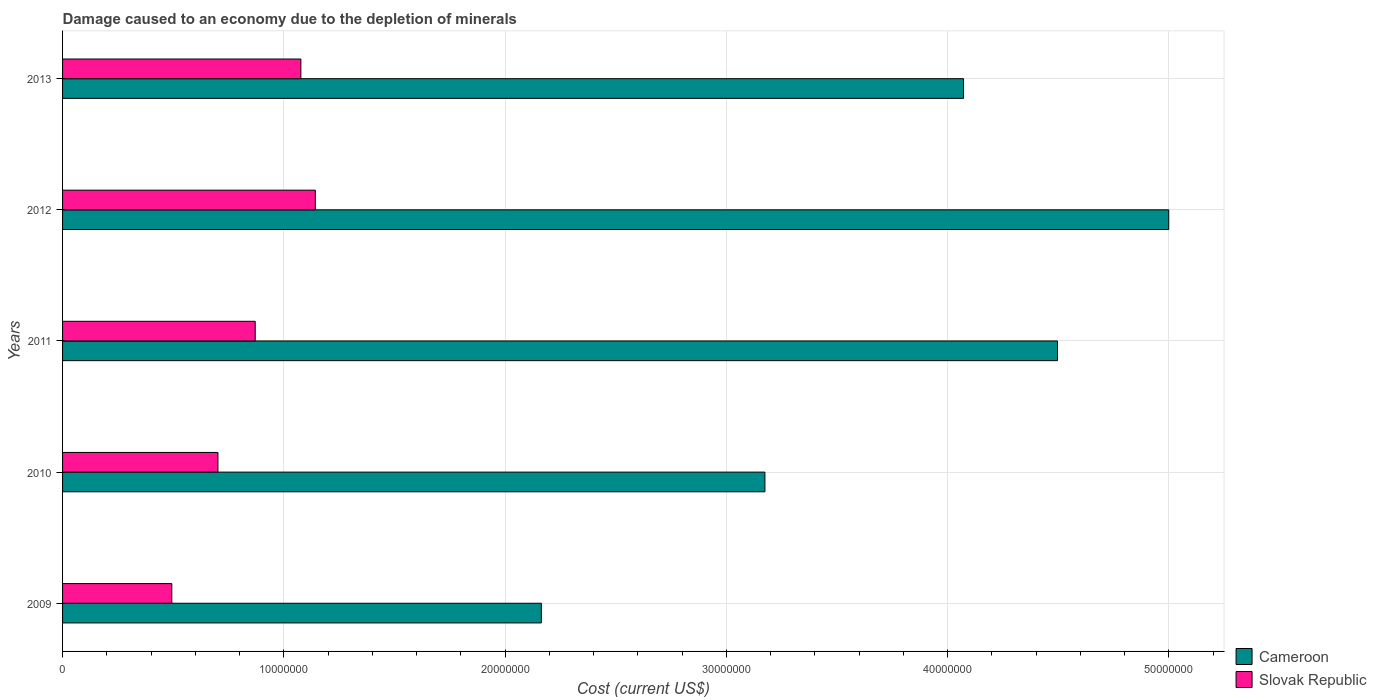How many groups of bars are there?
Provide a short and direct response. 5. Are the number of bars per tick equal to the number of legend labels?
Your answer should be compact. Yes. Are the number of bars on each tick of the Y-axis equal?
Offer a terse response. Yes. How many bars are there on the 4th tick from the bottom?
Make the answer very short. 2. What is the label of the 1st group of bars from the top?
Provide a short and direct response. 2013. What is the cost of damage caused due to the depletion of minerals in Slovak Republic in 2011?
Your answer should be very brief. 8.71e+06. Across all years, what is the maximum cost of damage caused due to the depletion of minerals in Slovak Republic?
Offer a terse response. 1.14e+07. Across all years, what is the minimum cost of damage caused due to the depletion of minerals in Cameroon?
Make the answer very short. 2.16e+07. What is the total cost of damage caused due to the depletion of minerals in Cameroon in the graph?
Provide a succinct answer. 1.89e+08. What is the difference between the cost of damage caused due to the depletion of minerals in Slovak Republic in 2009 and that in 2010?
Ensure brevity in your answer.  -2.08e+06. What is the difference between the cost of damage caused due to the depletion of minerals in Slovak Republic in 2010 and the cost of damage caused due to the depletion of minerals in Cameroon in 2012?
Your answer should be compact. -4.30e+07. What is the average cost of damage caused due to the depletion of minerals in Cameroon per year?
Your answer should be compact. 3.78e+07. In the year 2011, what is the difference between the cost of damage caused due to the depletion of minerals in Cameroon and cost of damage caused due to the depletion of minerals in Slovak Republic?
Your answer should be very brief. 3.63e+07. What is the ratio of the cost of damage caused due to the depletion of minerals in Cameroon in 2012 to that in 2013?
Provide a short and direct response. 1.23. Is the cost of damage caused due to the depletion of minerals in Cameroon in 2009 less than that in 2011?
Your answer should be very brief. Yes. Is the difference between the cost of damage caused due to the depletion of minerals in Cameroon in 2010 and 2011 greater than the difference between the cost of damage caused due to the depletion of minerals in Slovak Republic in 2010 and 2011?
Provide a short and direct response. No. What is the difference between the highest and the second highest cost of damage caused due to the depletion of minerals in Cameroon?
Your answer should be compact. 5.03e+06. What is the difference between the highest and the lowest cost of damage caused due to the depletion of minerals in Slovak Republic?
Provide a short and direct response. 6.49e+06. In how many years, is the cost of damage caused due to the depletion of minerals in Slovak Republic greater than the average cost of damage caused due to the depletion of minerals in Slovak Republic taken over all years?
Make the answer very short. 3. What does the 1st bar from the top in 2012 represents?
Your response must be concise. Slovak Republic. What does the 2nd bar from the bottom in 2011 represents?
Give a very brief answer. Slovak Republic. How many bars are there?
Keep it short and to the point. 10. How many years are there in the graph?
Your answer should be very brief. 5. Are the values on the major ticks of X-axis written in scientific E-notation?
Offer a very short reply. No. Does the graph contain any zero values?
Your answer should be compact. No. Does the graph contain grids?
Provide a short and direct response. Yes. What is the title of the graph?
Keep it short and to the point. Damage caused to an economy due to the depletion of minerals. Does "Cote d'Ivoire" appear as one of the legend labels in the graph?
Give a very brief answer. No. What is the label or title of the X-axis?
Offer a very short reply. Cost (current US$). What is the label or title of the Y-axis?
Offer a terse response. Years. What is the Cost (current US$) in Cameroon in 2009?
Provide a succinct answer. 2.16e+07. What is the Cost (current US$) of Slovak Republic in 2009?
Your answer should be compact. 4.94e+06. What is the Cost (current US$) in Cameroon in 2010?
Ensure brevity in your answer.  3.17e+07. What is the Cost (current US$) of Slovak Republic in 2010?
Your answer should be compact. 7.02e+06. What is the Cost (current US$) in Cameroon in 2011?
Make the answer very short. 4.50e+07. What is the Cost (current US$) in Slovak Republic in 2011?
Your answer should be compact. 8.71e+06. What is the Cost (current US$) in Cameroon in 2012?
Offer a terse response. 5.00e+07. What is the Cost (current US$) of Slovak Republic in 2012?
Your answer should be compact. 1.14e+07. What is the Cost (current US$) of Cameroon in 2013?
Your response must be concise. 4.07e+07. What is the Cost (current US$) of Slovak Republic in 2013?
Provide a short and direct response. 1.08e+07. Across all years, what is the maximum Cost (current US$) of Cameroon?
Your response must be concise. 5.00e+07. Across all years, what is the maximum Cost (current US$) of Slovak Republic?
Make the answer very short. 1.14e+07. Across all years, what is the minimum Cost (current US$) in Cameroon?
Provide a succinct answer. 2.16e+07. Across all years, what is the minimum Cost (current US$) in Slovak Republic?
Provide a succinct answer. 4.94e+06. What is the total Cost (current US$) of Cameroon in the graph?
Give a very brief answer. 1.89e+08. What is the total Cost (current US$) in Slovak Republic in the graph?
Your answer should be compact. 4.29e+07. What is the difference between the Cost (current US$) in Cameroon in 2009 and that in 2010?
Your response must be concise. -1.01e+07. What is the difference between the Cost (current US$) in Slovak Republic in 2009 and that in 2010?
Make the answer very short. -2.08e+06. What is the difference between the Cost (current US$) of Cameroon in 2009 and that in 2011?
Ensure brevity in your answer.  -2.33e+07. What is the difference between the Cost (current US$) in Slovak Republic in 2009 and that in 2011?
Offer a terse response. -3.77e+06. What is the difference between the Cost (current US$) of Cameroon in 2009 and that in 2012?
Ensure brevity in your answer.  -2.84e+07. What is the difference between the Cost (current US$) of Slovak Republic in 2009 and that in 2012?
Your answer should be very brief. -6.49e+06. What is the difference between the Cost (current US$) in Cameroon in 2009 and that in 2013?
Your answer should be compact. -1.91e+07. What is the difference between the Cost (current US$) in Slovak Republic in 2009 and that in 2013?
Keep it short and to the point. -5.83e+06. What is the difference between the Cost (current US$) in Cameroon in 2010 and that in 2011?
Offer a very short reply. -1.32e+07. What is the difference between the Cost (current US$) of Slovak Republic in 2010 and that in 2011?
Give a very brief answer. -1.68e+06. What is the difference between the Cost (current US$) of Cameroon in 2010 and that in 2012?
Your answer should be compact. -1.83e+07. What is the difference between the Cost (current US$) in Slovak Republic in 2010 and that in 2012?
Make the answer very short. -4.40e+06. What is the difference between the Cost (current US$) of Cameroon in 2010 and that in 2013?
Provide a succinct answer. -8.98e+06. What is the difference between the Cost (current US$) in Slovak Republic in 2010 and that in 2013?
Ensure brevity in your answer.  -3.75e+06. What is the difference between the Cost (current US$) of Cameroon in 2011 and that in 2012?
Provide a short and direct response. -5.03e+06. What is the difference between the Cost (current US$) of Slovak Republic in 2011 and that in 2012?
Make the answer very short. -2.72e+06. What is the difference between the Cost (current US$) in Cameroon in 2011 and that in 2013?
Give a very brief answer. 4.25e+06. What is the difference between the Cost (current US$) in Slovak Republic in 2011 and that in 2013?
Offer a very short reply. -2.06e+06. What is the difference between the Cost (current US$) in Cameroon in 2012 and that in 2013?
Your response must be concise. 9.27e+06. What is the difference between the Cost (current US$) in Slovak Republic in 2012 and that in 2013?
Ensure brevity in your answer.  6.55e+05. What is the difference between the Cost (current US$) in Cameroon in 2009 and the Cost (current US$) in Slovak Republic in 2010?
Ensure brevity in your answer.  1.46e+07. What is the difference between the Cost (current US$) in Cameroon in 2009 and the Cost (current US$) in Slovak Republic in 2011?
Make the answer very short. 1.29e+07. What is the difference between the Cost (current US$) of Cameroon in 2009 and the Cost (current US$) of Slovak Republic in 2012?
Provide a succinct answer. 1.02e+07. What is the difference between the Cost (current US$) in Cameroon in 2009 and the Cost (current US$) in Slovak Republic in 2013?
Offer a very short reply. 1.09e+07. What is the difference between the Cost (current US$) of Cameroon in 2010 and the Cost (current US$) of Slovak Republic in 2011?
Make the answer very short. 2.30e+07. What is the difference between the Cost (current US$) in Cameroon in 2010 and the Cost (current US$) in Slovak Republic in 2012?
Offer a very short reply. 2.03e+07. What is the difference between the Cost (current US$) of Cameroon in 2010 and the Cost (current US$) of Slovak Republic in 2013?
Your answer should be very brief. 2.10e+07. What is the difference between the Cost (current US$) in Cameroon in 2011 and the Cost (current US$) in Slovak Republic in 2012?
Make the answer very short. 3.35e+07. What is the difference between the Cost (current US$) in Cameroon in 2011 and the Cost (current US$) in Slovak Republic in 2013?
Ensure brevity in your answer.  3.42e+07. What is the difference between the Cost (current US$) of Cameroon in 2012 and the Cost (current US$) of Slovak Republic in 2013?
Keep it short and to the point. 3.92e+07. What is the average Cost (current US$) of Cameroon per year?
Give a very brief answer. 3.78e+07. What is the average Cost (current US$) in Slovak Republic per year?
Offer a terse response. 8.57e+06. In the year 2009, what is the difference between the Cost (current US$) of Cameroon and Cost (current US$) of Slovak Republic?
Provide a succinct answer. 1.67e+07. In the year 2010, what is the difference between the Cost (current US$) in Cameroon and Cost (current US$) in Slovak Republic?
Provide a short and direct response. 2.47e+07. In the year 2011, what is the difference between the Cost (current US$) in Cameroon and Cost (current US$) in Slovak Republic?
Keep it short and to the point. 3.63e+07. In the year 2012, what is the difference between the Cost (current US$) of Cameroon and Cost (current US$) of Slovak Republic?
Your response must be concise. 3.86e+07. In the year 2013, what is the difference between the Cost (current US$) of Cameroon and Cost (current US$) of Slovak Republic?
Provide a short and direct response. 3.00e+07. What is the ratio of the Cost (current US$) of Cameroon in 2009 to that in 2010?
Your answer should be compact. 0.68. What is the ratio of the Cost (current US$) of Slovak Republic in 2009 to that in 2010?
Your answer should be compact. 0.7. What is the ratio of the Cost (current US$) of Cameroon in 2009 to that in 2011?
Give a very brief answer. 0.48. What is the ratio of the Cost (current US$) of Slovak Republic in 2009 to that in 2011?
Make the answer very short. 0.57. What is the ratio of the Cost (current US$) in Cameroon in 2009 to that in 2012?
Offer a terse response. 0.43. What is the ratio of the Cost (current US$) of Slovak Republic in 2009 to that in 2012?
Your answer should be compact. 0.43. What is the ratio of the Cost (current US$) of Cameroon in 2009 to that in 2013?
Your response must be concise. 0.53. What is the ratio of the Cost (current US$) of Slovak Republic in 2009 to that in 2013?
Your response must be concise. 0.46. What is the ratio of the Cost (current US$) in Cameroon in 2010 to that in 2011?
Provide a succinct answer. 0.71. What is the ratio of the Cost (current US$) of Slovak Republic in 2010 to that in 2011?
Offer a terse response. 0.81. What is the ratio of the Cost (current US$) of Cameroon in 2010 to that in 2012?
Your response must be concise. 0.63. What is the ratio of the Cost (current US$) in Slovak Republic in 2010 to that in 2012?
Provide a succinct answer. 0.61. What is the ratio of the Cost (current US$) in Cameroon in 2010 to that in 2013?
Your answer should be compact. 0.78. What is the ratio of the Cost (current US$) of Slovak Republic in 2010 to that in 2013?
Keep it short and to the point. 0.65. What is the ratio of the Cost (current US$) in Cameroon in 2011 to that in 2012?
Your answer should be very brief. 0.9. What is the ratio of the Cost (current US$) in Slovak Republic in 2011 to that in 2012?
Give a very brief answer. 0.76. What is the ratio of the Cost (current US$) in Cameroon in 2011 to that in 2013?
Provide a succinct answer. 1.1. What is the ratio of the Cost (current US$) in Slovak Republic in 2011 to that in 2013?
Your answer should be very brief. 0.81. What is the ratio of the Cost (current US$) in Cameroon in 2012 to that in 2013?
Make the answer very short. 1.23. What is the ratio of the Cost (current US$) in Slovak Republic in 2012 to that in 2013?
Offer a very short reply. 1.06. What is the difference between the highest and the second highest Cost (current US$) in Cameroon?
Provide a succinct answer. 5.03e+06. What is the difference between the highest and the second highest Cost (current US$) in Slovak Republic?
Your answer should be very brief. 6.55e+05. What is the difference between the highest and the lowest Cost (current US$) in Cameroon?
Ensure brevity in your answer.  2.84e+07. What is the difference between the highest and the lowest Cost (current US$) in Slovak Republic?
Provide a succinct answer. 6.49e+06. 